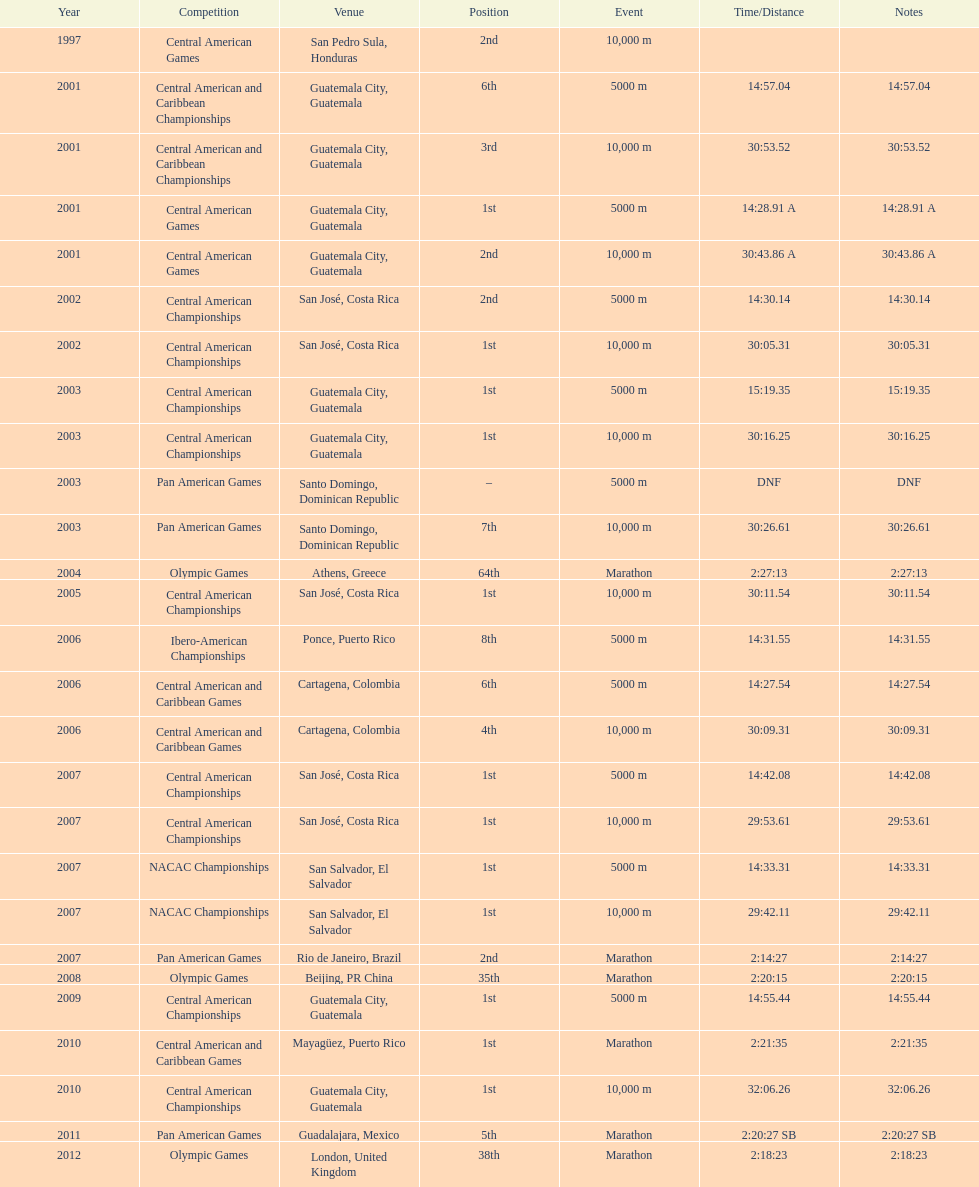Which event is listed more between the 10,000m and the 5000m? 10,000 m. 